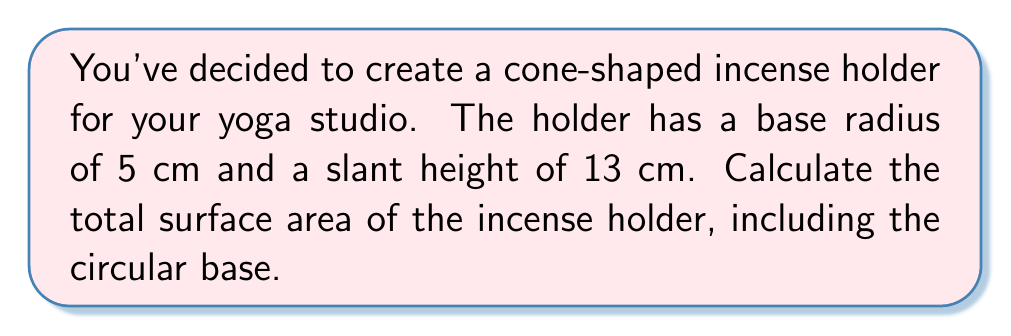Teach me how to tackle this problem. To find the surface area of a cone-shaped incense holder, we need to calculate the lateral surface area and add it to the area of the circular base.

Step 1: Calculate the lateral surface area.
The formula for the lateral surface area of a cone is:
$$A_l = \pi rs$$
Where $r$ is the radius of the base and $s$ is the slant height.

$A_l = \pi \cdot 5 \cdot 13 = 65\pi$ cm²

Step 2: Calculate the area of the circular base.
The formula for the area of a circle is:
$$A_b = \pi r^2$$

$A_b = \pi \cdot 5^2 = 25\pi$ cm²

Step 3: Calculate the total surface area by adding the lateral surface area and the base area.
$$A_{total} = A_l + A_b = 65\pi + 25\pi = 90\pi$$ cm²

[asy]
import geometry;

size(200);
pair O=(0,0), A=(5,0), B=(0,12);
draw(O--A--B--cycle);
draw(Arc(O,A,180));
label("5 cm",A/2,S);
label("13 cm",(A+B)/2,NE);
label("r = 5 cm",O,SW);
[/asy]
Answer: $90\pi$ cm² 